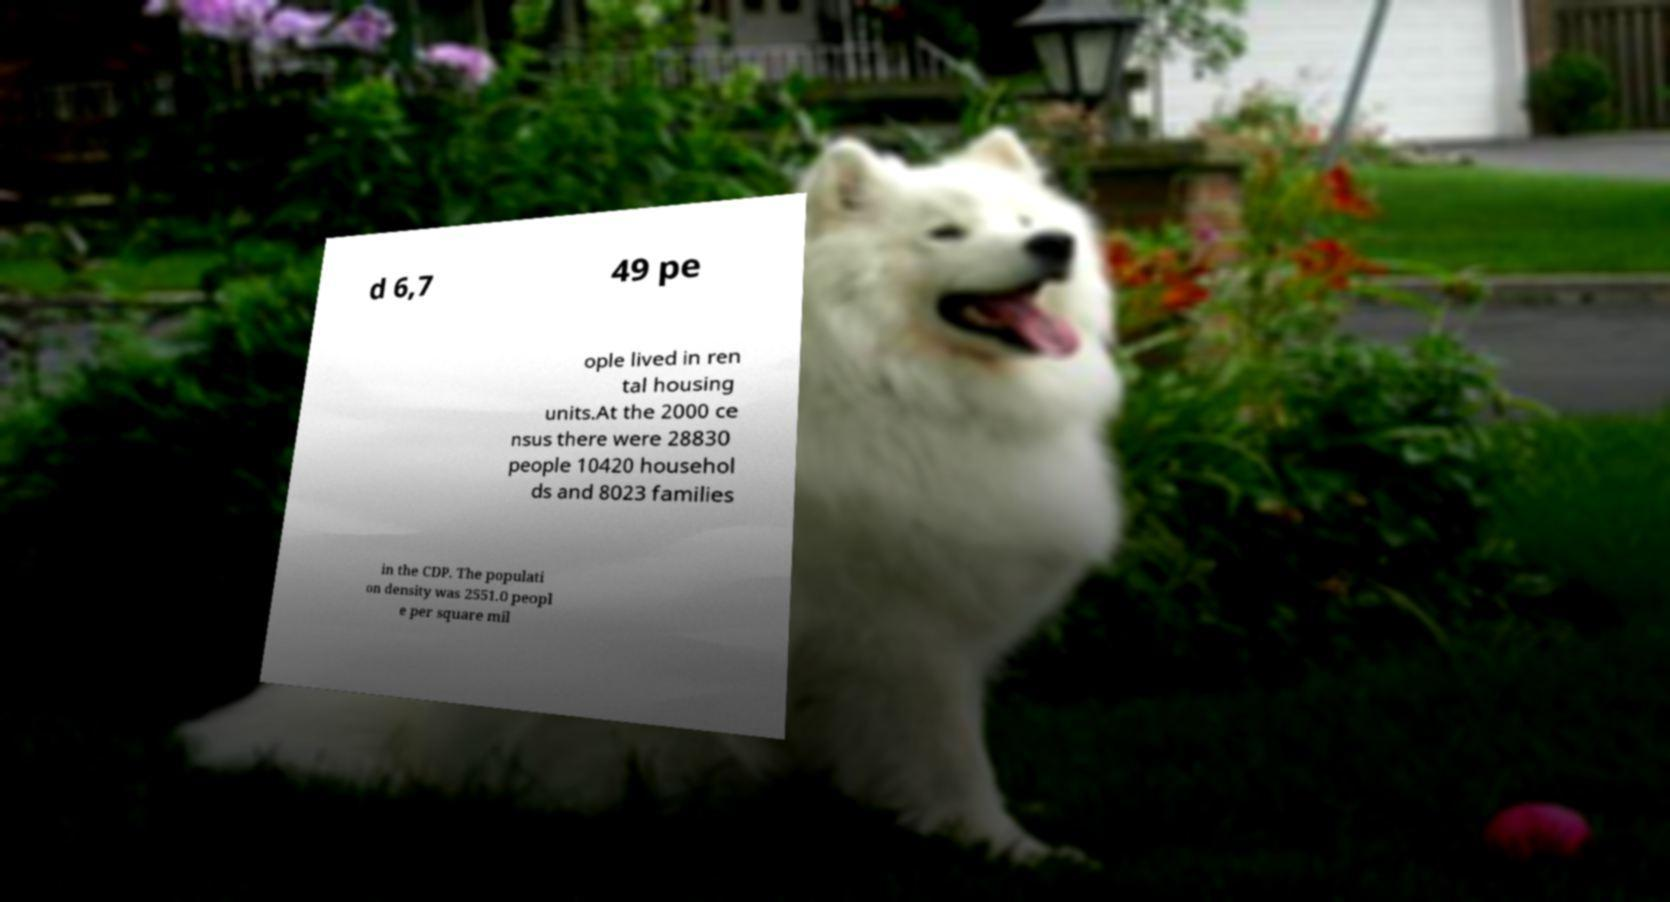Can you read and provide the text displayed in the image?This photo seems to have some interesting text. Can you extract and type it out for me? d 6,7 49 pe ople lived in ren tal housing units.At the 2000 ce nsus there were 28830 people 10420 househol ds and 8023 families in the CDP. The populati on density was 2551.0 peopl e per square mil 